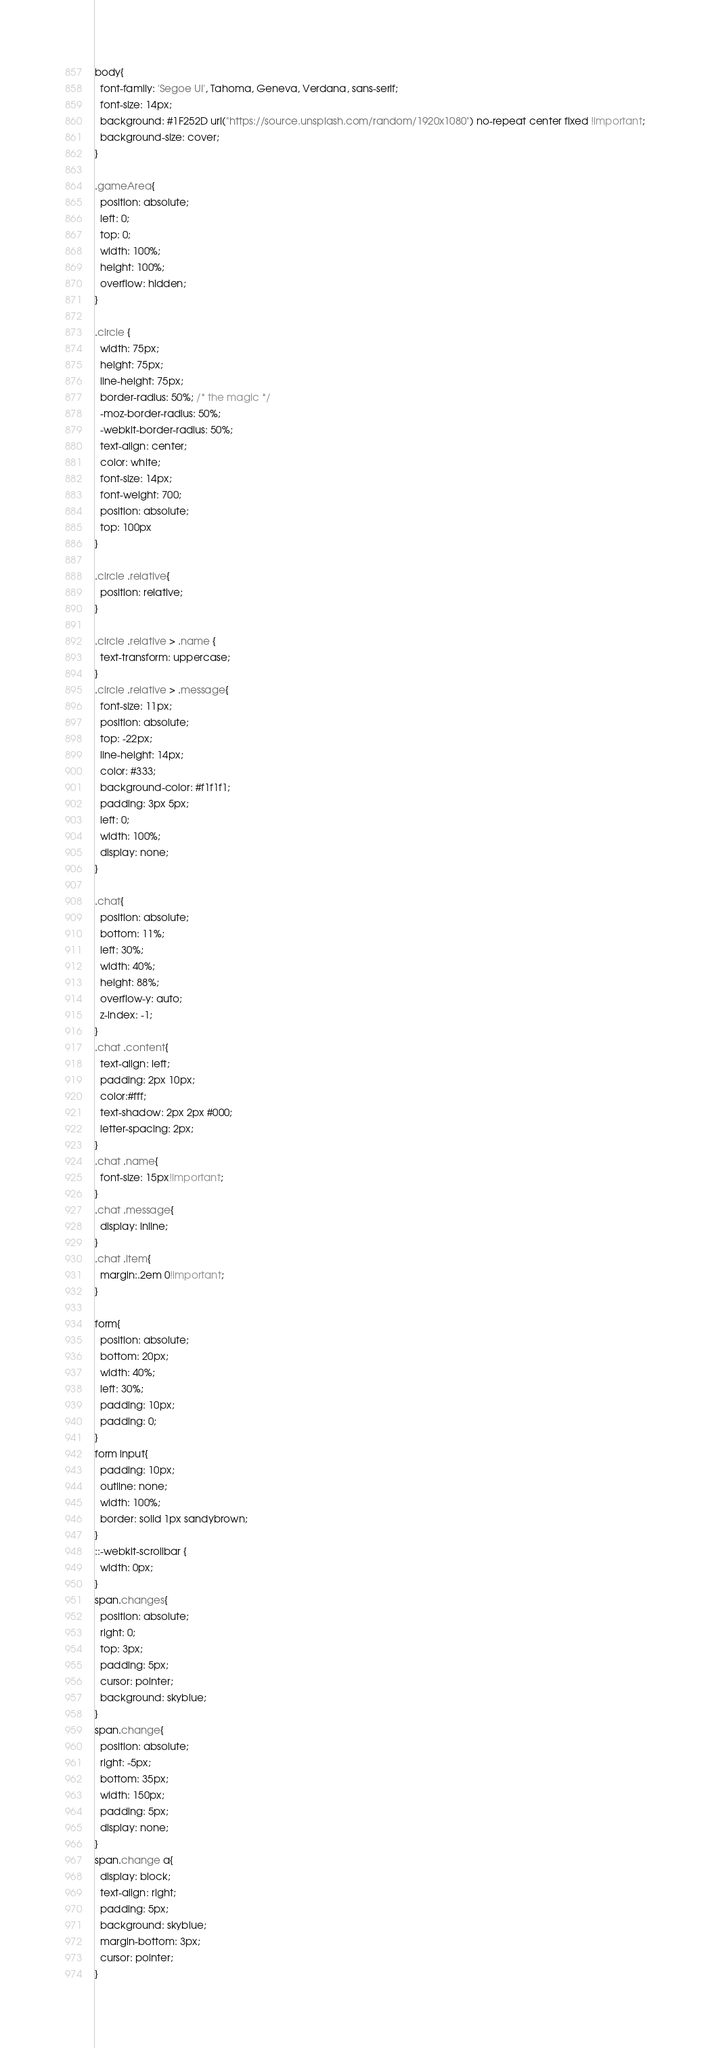Convert code to text. <code><loc_0><loc_0><loc_500><loc_500><_CSS_>body{
  font-family: 'Segoe UI', Tahoma, Geneva, Verdana, sans-serif;
  font-size: 14px;
  background: #1F252D url("https://source.unsplash.com/random/1920x1080") no-repeat center fixed !important;
  background-size: cover;
}

.gameArea{
  position: absolute;
  left: 0;
  top: 0;
  width: 100%;
  height: 100%;
  overflow: hidden;
}

.circle {
  width: 75px;
  height: 75px;
  line-height: 75px;
  border-radius: 50%; /* the magic */
  -moz-border-radius: 50%;
  -webkit-border-radius: 50%;
  text-align: center;
  color: white;
  font-size: 14px;
  font-weight: 700;
  position: absolute;
  top: 100px
}

.circle .relative{
  position: relative;
}

.circle .relative > .name {
  text-transform: uppercase;
}
.circle .relative > .message{
  font-size: 11px;
  position: absolute;
  top: -22px;
  line-height: 14px;
  color: #333;
  background-color: #f1f1f1;
  padding: 3px 5px;
  left: 0;
  width: 100%;
  display: none;
}

.chat{
  position: absolute;
  bottom: 11%;
  left: 30%;
  width: 40%;
  height: 88%;
  overflow-y: auto;
  z-index: -1;
}
.chat .content{
  text-align: left;
  padding: 2px 10px;
  color:#fff;
  text-shadow: 2px 2px #000;
  letter-spacing: 2px;
}
.chat .name{
  font-size: 15px!important;
}
.chat .message{
  display: inline;
}
.chat .item{
  margin:.2em 0!important;
}

form{
  position: absolute;
  bottom: 20px;
  width: 40%;
  left: 30%;
  padding: 10px;
  padding: 0;
}
form input{
  padding: 10px;
  outline: none;
  width: 100%;
  border: solid 1px sandybrown;
}
::-webkit-scrollbar {
  width: 0px;
}
span.changes{
  position: absolute;
  right: 0;
  top: 3px;
  padding: 5px;
  cursor: pointer;
  background: skyblue;
}
span.change{
  position: absolute;
  right: -5px;
  bottom: 35px;
  width: 150px;
  padding: 5px;
  display: none;
}
span.change a{
  display: block;
  text-align: right;
  padding: 5px;
  background: skyblue;
  margin-bottom: 3px;
  cursor: pointer;
}</code> 